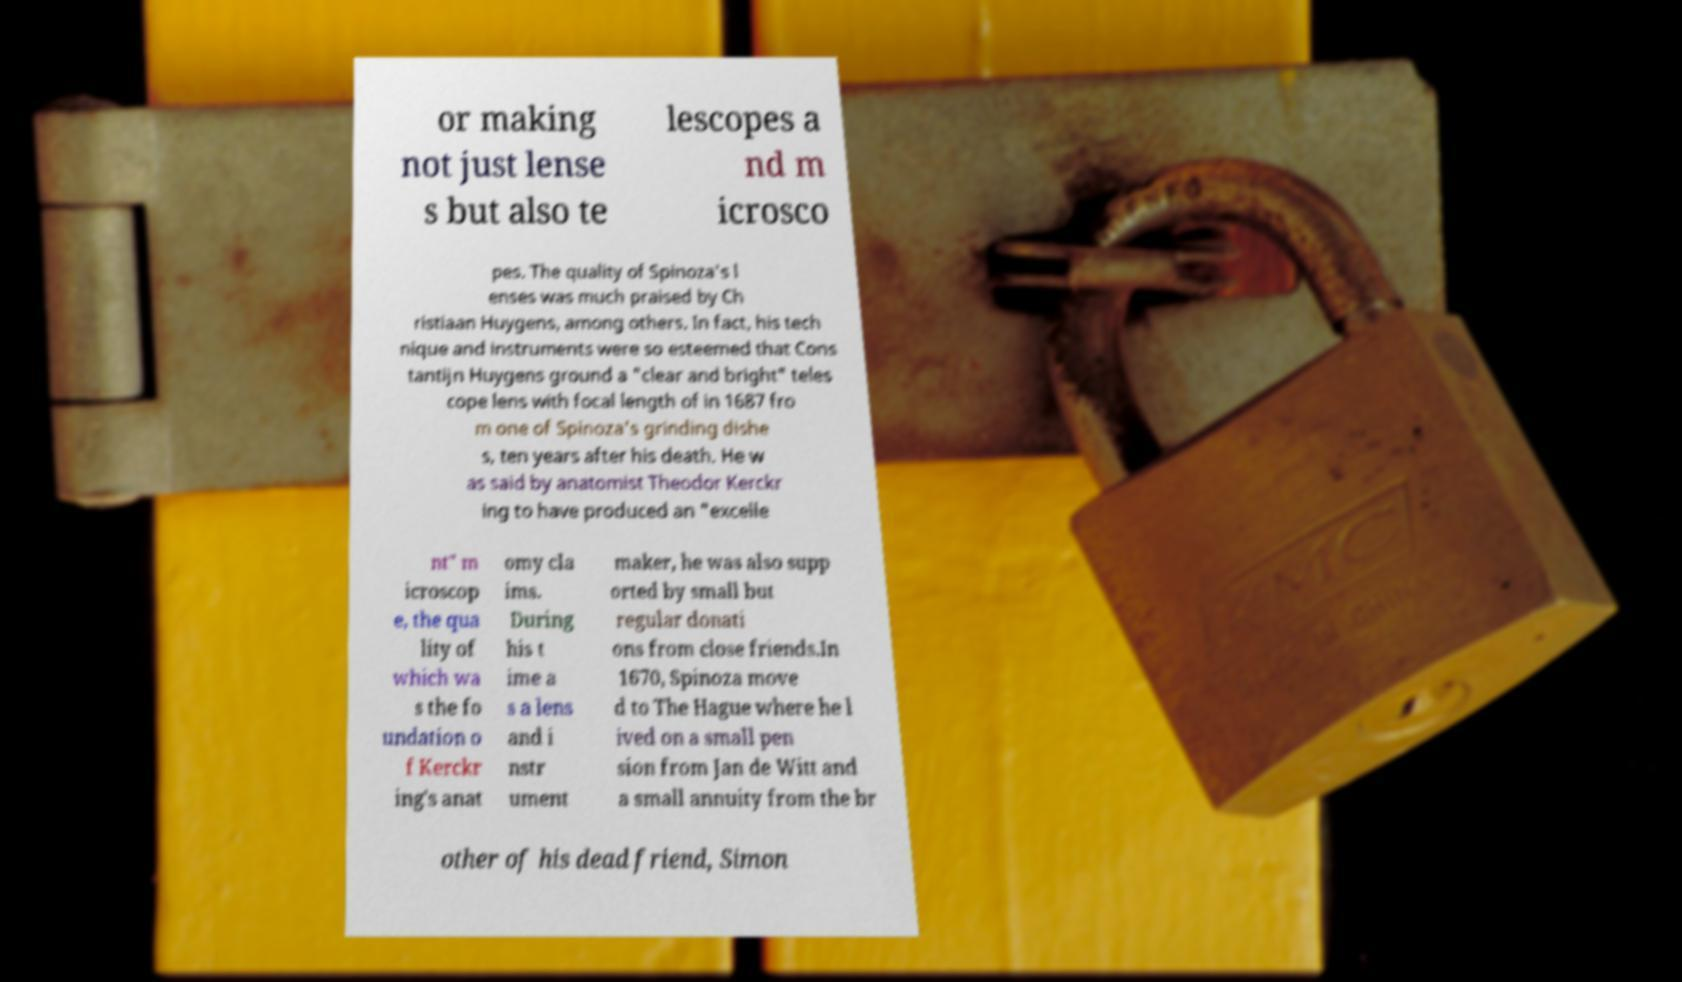Can you read and provide the text displayed in the image?This photo seems to have some interesting text. Can you extract and type it out for me? or making not just lense s but also te lescopes a nd m icrosco pes. The quality of Spinoza's l enses was much praised by Ch ristiaan Huygens, among others. In fact, his tech nique and instruments were so esteemed that Cons tantijn Huygens ground a "clear and bright" teles cope lens with focal length of in 1687 fro m one of Spinoza's grinding dishe s, ten years after his death. He w as said by anatomist Theodor Kerckr ing to have produced an "excelle nt" m icroscop e, the qua lity of which wa s the fo undation o f Kerckr ing's anat omy cla ims. During his t ime a s a lens and i nstr ument maker, he was also supp orted by small but regular donati ons from close friends.In 1670, Spinoza move d to The Hague where he l ived on a small pen sion from Jan de Witt and a small annuity from the br other of his dead friend, Simon 